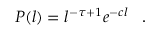Convert formula to latex. <formula><loc_0><loc_0><loc_500><loc_500>P ( l ) = l ^ { - \tau + 1 } e ^ { - c l } \, . \,</formula> 